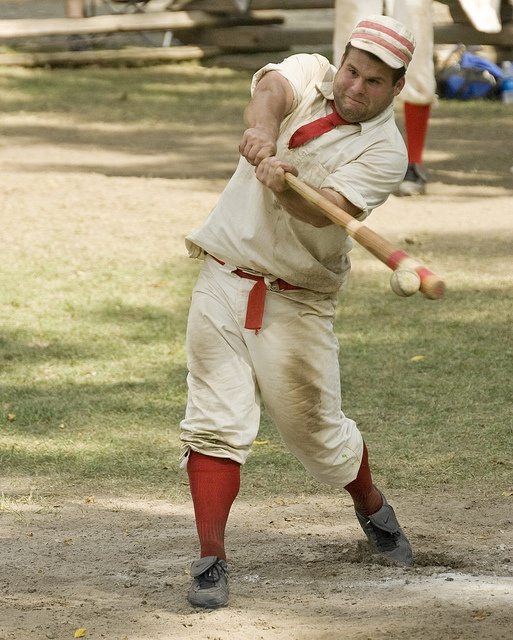Describe the objects in this image and their specific colors. I can see people in tan and lightgray tones, people in tan, beige, and maroon tones, baseball bat in tan, olive, and gray tones, tie in tan, brown, and maroon tones, and sports ball in tan and olive tones in this image. 